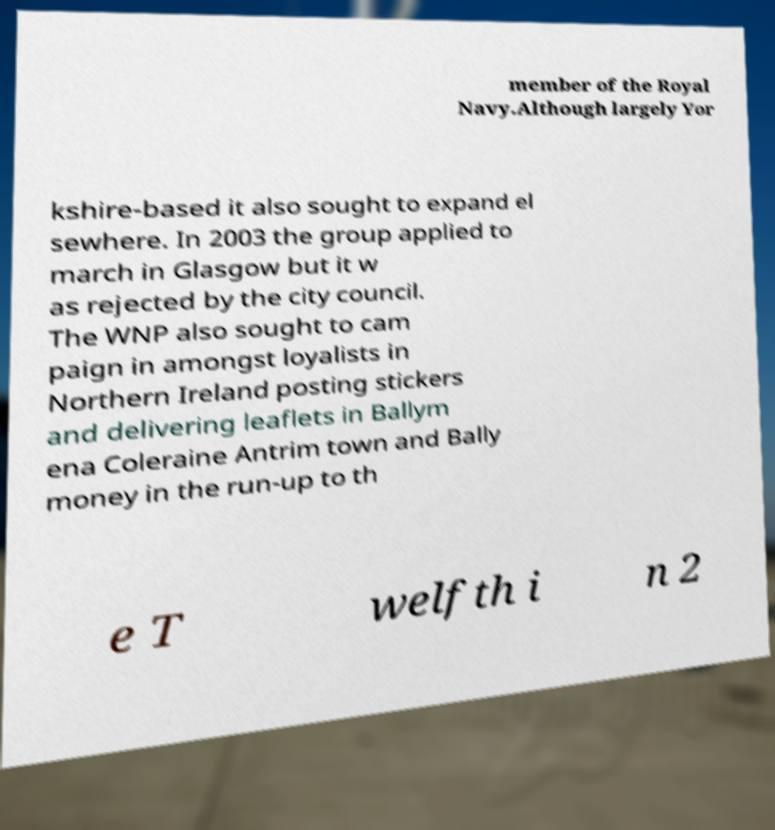Please read and relay the text visible in this image. What does it say? member of the Royal Navy.Although largely Yor kshire-based it also sought to expand el sewhere. In 2003 the group applied to march in Glasgow but it w as rejected by the city council. The WNP also sought to cam paign in amongst loyalists in Northern Ireland posting stickers and delivering leaflets in Ballym ena Coleraine Antrim town and Bally money in the run-up to th e T welfth i n 2 